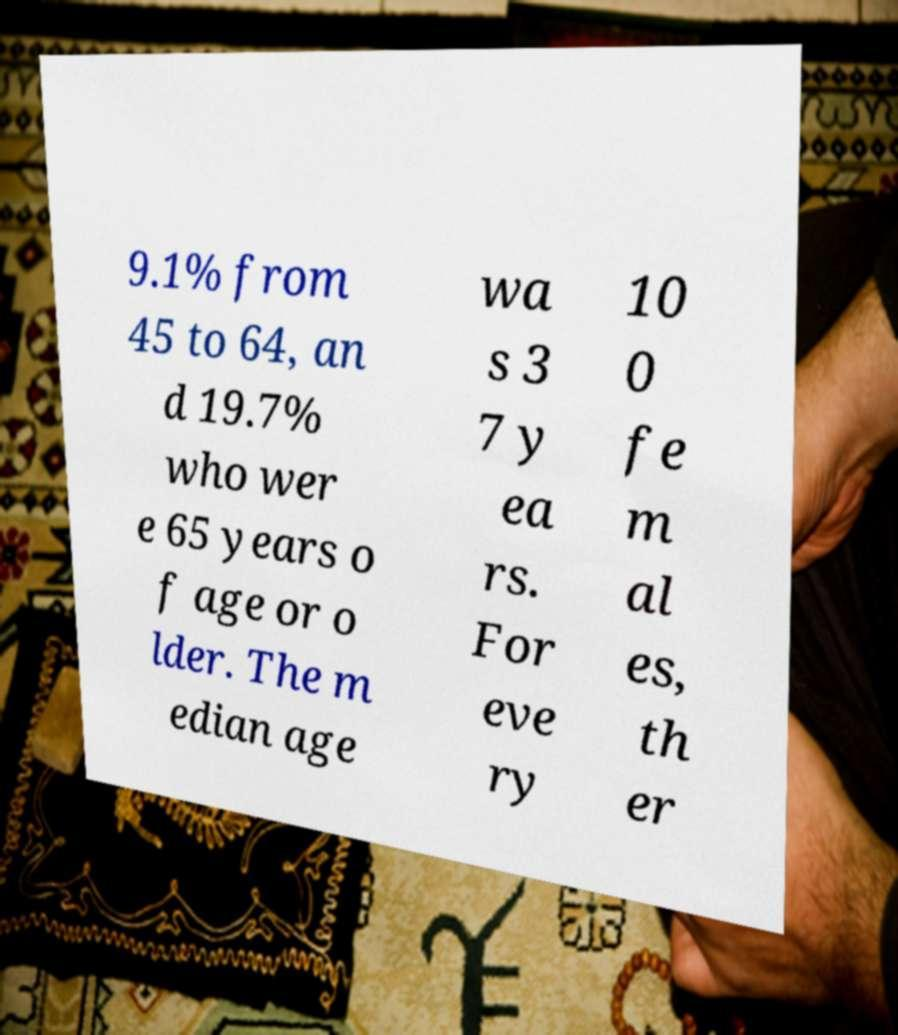Please identify and transcribe the text found in this image. 9.1% from 45 to 64, an d 19.7% who wer e 65 years o f age or o lder. The m edian age wa s 3 7 y ea rs. For eve ry 10 0 fe m al es, th er 